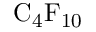Convert formula to latex. <formula><loc_0><loc_0><loc_500><loc_500>C _ { 4 } F _ { 1 0 }</formula> 